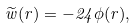Convert formula to latex. <formula><loc_0><loc_0><loc_500><loc_500>\widetilde { w } ( r ) = - 2 4 \phi ( r ) ,</formula> 